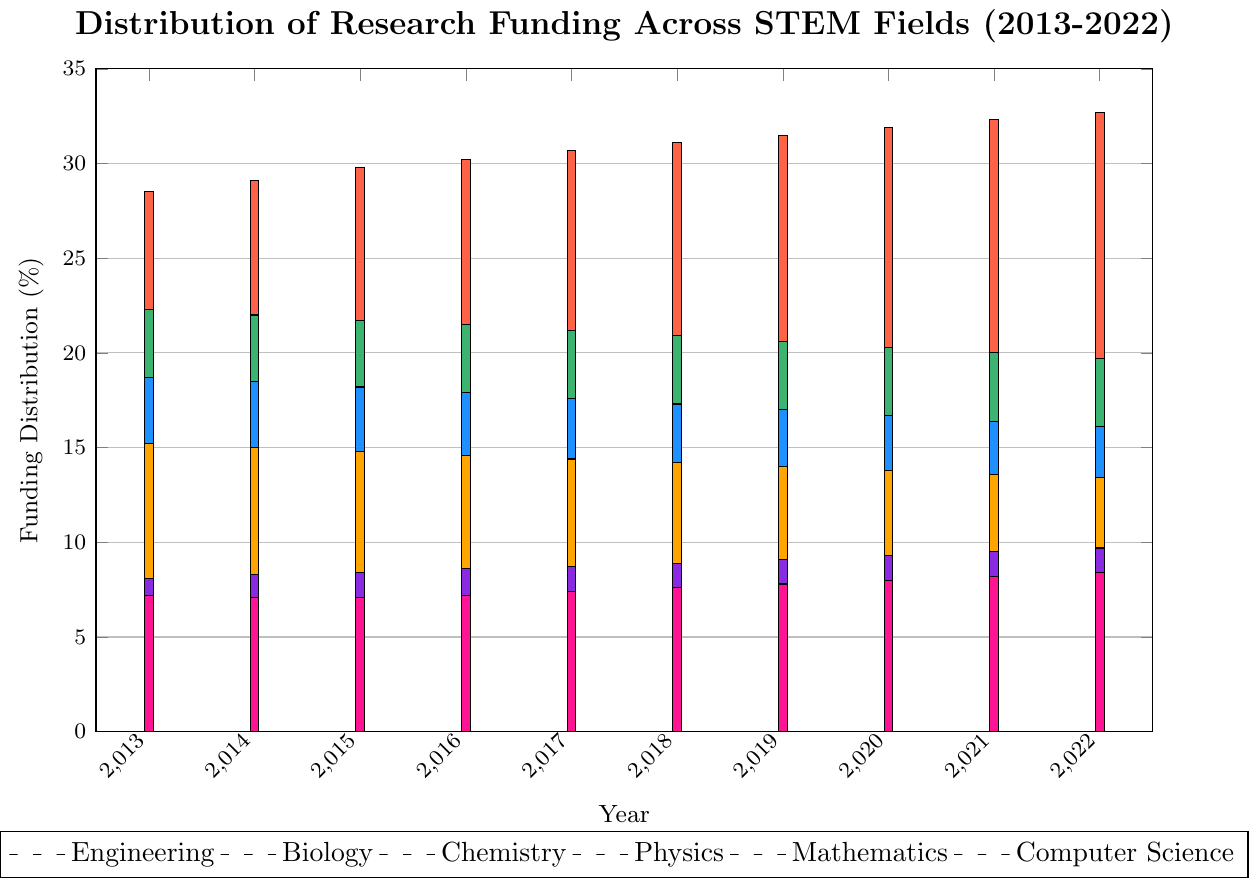What is the percentage difference in funding between Engineering and Biology in 2022? The funding for Engineering in 2022 is 32.7% and for Biology is 19.7%. The difference is 32.7 - 19.7 = 13%.
Answer: 13% Which year shows the highest funding for Mathematics? To find the highest funding, compare the values for Mathematics across all years. 2022 has the highest value at 9.7%.
Answer: 2022 Compare the funding trend for Chemistry and Physics over the decade. Which field had a steeper decline? From 2013 to 2022, Chemistry funding declined from 18.7% to 16.1%, a decrease of 2.6%. Physics funding declined from 15.2% to 13.4%, a decrease of 1.8%. Chemistry had a steeper decline.
Answer: Chemistry Identify the field with the most consistent funding percentage over the decade. By observing the bar heights, Computer Science shows the least fluctuation, with values ranging only from 7.1% to 8.4%.
Answer: Computer Science In which year was the funding for Computer Science closest to the funding for Mathematics? Using the bar heights, in 2020, the funding for Computer Science was 8.0% and for Mathematics was 9.3%, the closest gap of 1.3%.
Answer: 2020 Which field’s funding remained above 20% throughout the entire decade? By observing the bars, only Engineering and Biology started and remained above 20% throughout the decade.
Answer: Engineering and Biology What is the average funding percentage for Physics over the decade? Add the percentages for Physics from each year and divide by the number of years: (15.2 + 15.0 + 14.8 + 14.6 + 14.4 + 14.2 + 14.0 + 13.8 + 13.6 + 13.4) / 10 = 14.3%.
Answer: 14.3% Which field saw the largest gain in funding percentage from 2013 to 2022? To determine the largest gain, compare 2013 and 2022 values: Engineering 28.5% to 32.7% (gain of 4.2%), and other gains are smaller.
Answer: Engineering What was the total funding percentage for STEM fields excluding Engineering in 2015? Subtract the Engineering percentage from 100%: 100 - 29.8 = 70.2%.
Answer: 70.2% Identify if there was any year where the funding for Chemistry was exactly equal to the funding for Computer Science. Comparing the bars, no year shows matching percentages for funding in Chemistry and Computer Science.
Answer: No 